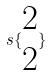Convert formula to latex. <formula><loc_0><loc_0><loc_500><loc_500>s \{ \begin{matrix} 2 \\ 2 \end{matrix} \}</formula> 